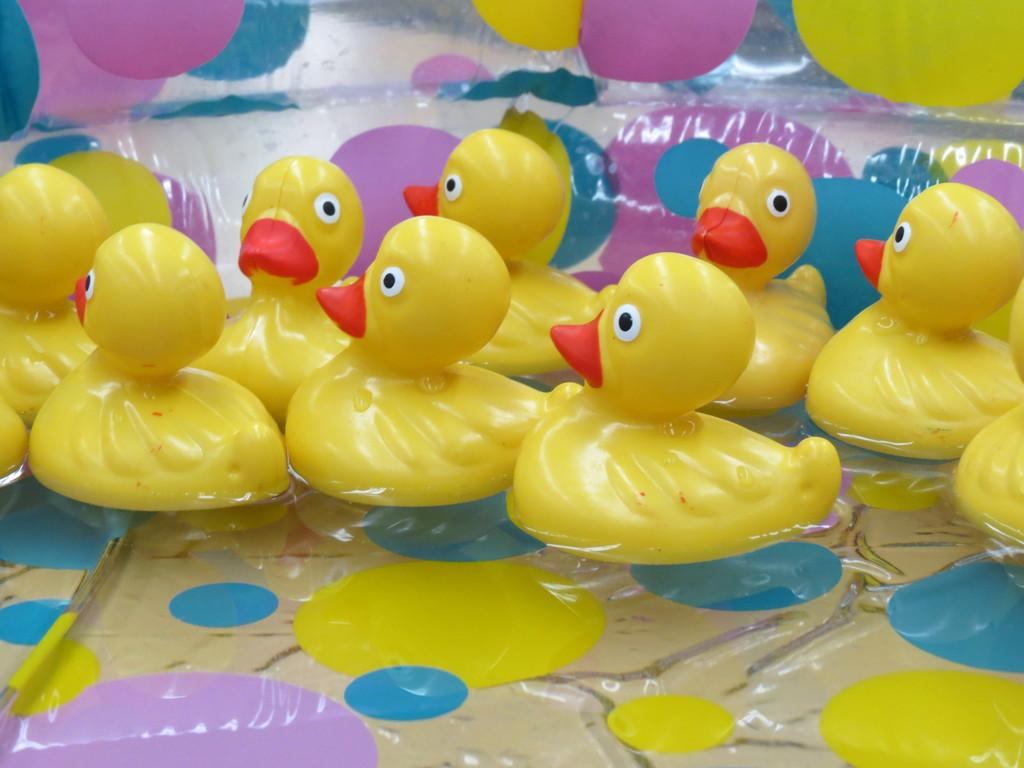What type of toys are in the image? There are toy ducks in the image. Where are the toy ducks located? The toy ducks are in the water. What color are the toy ducks? The toy ducks are yellow in color. What color are the beaks of the toy ducks? The beaks of the toy ducks are red in color. What type of prose can be heard being read by the toy ducks in the image? There is no indication in the image that the toy ducks are reading or producing any prose. 